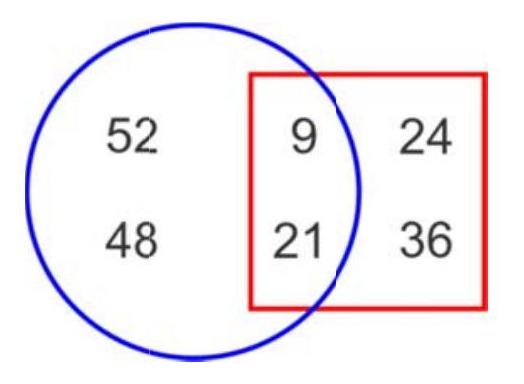How many numbers are outside the square?
 Answer is 2. 